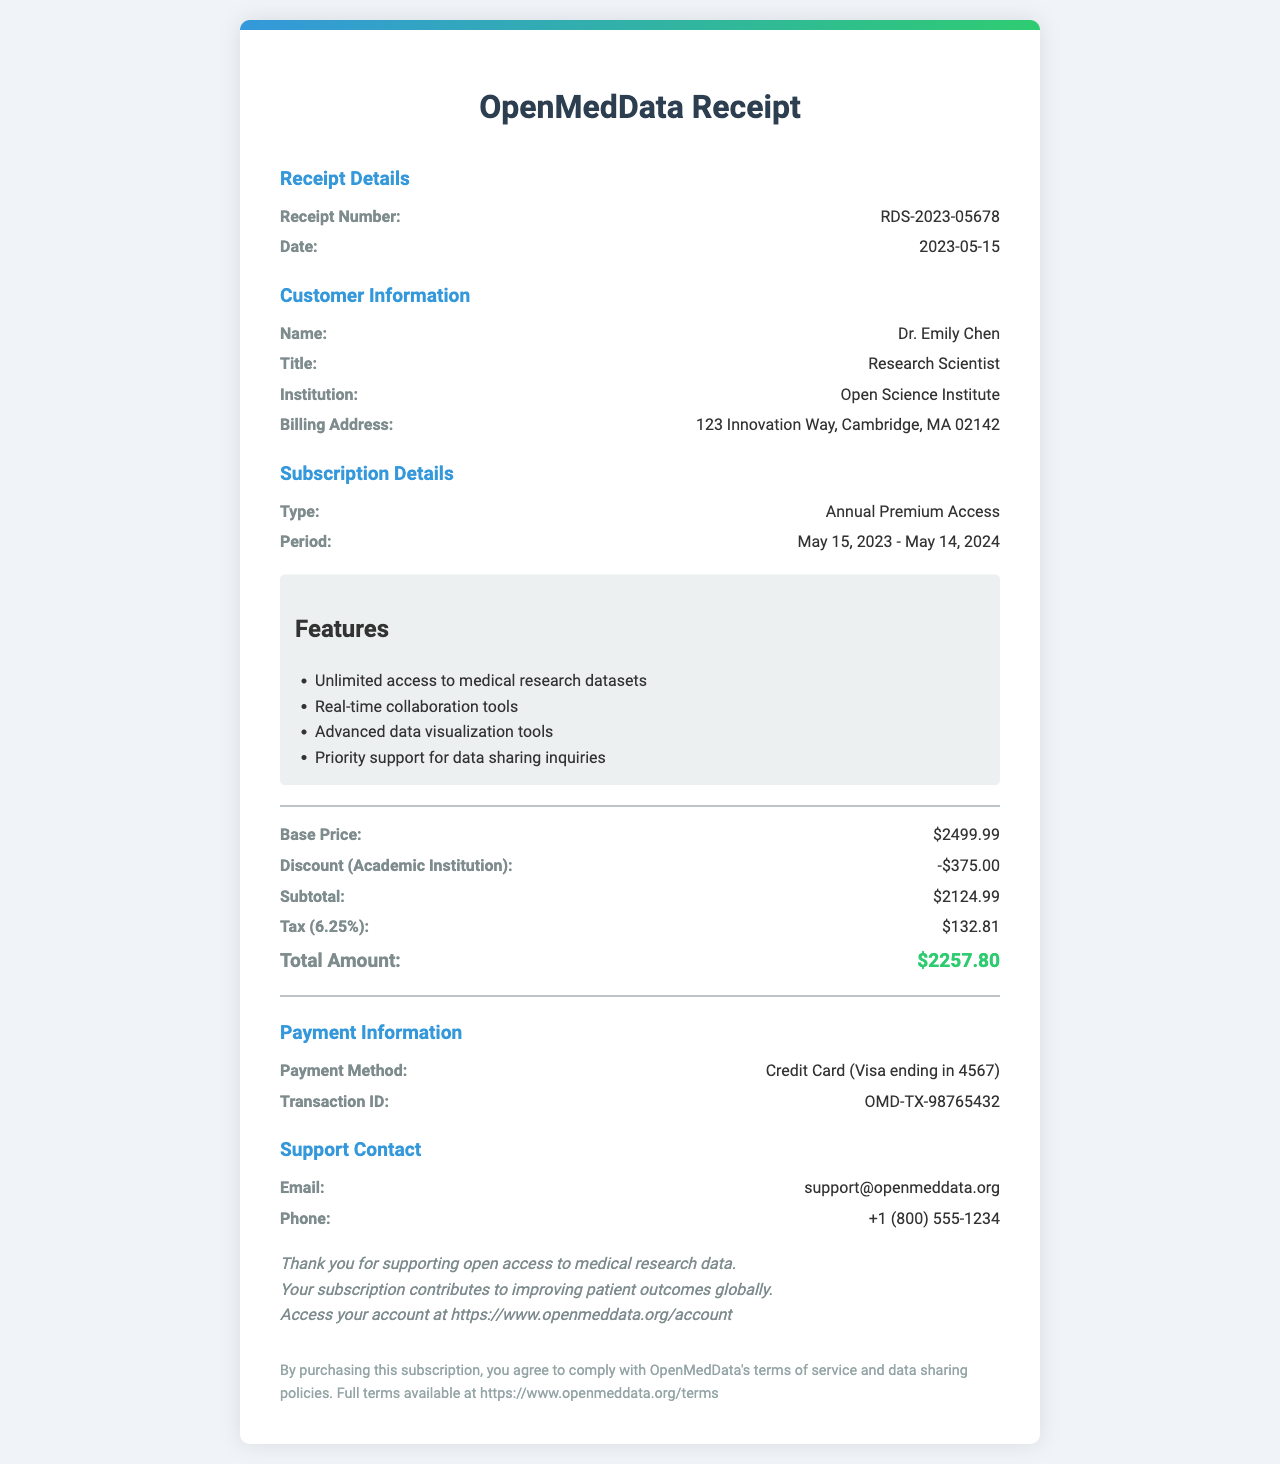What is the receipt number? The receipt number is a unique identifier for the transaction, which is RDS-2023-05678.
Answer: RDS-2023-05678 Who is the customer? The customer is identified by name, title, and institution, which is Dr. Emily Chen from the Open Science Institute.
Answer: Dr. Emily Chen What is the subscription type? The subscription type refers to the kind of access purchased, which is Annual Premium Access.
Answer: Annual Premium Access What discount was applied? The receipt shows the type of discount offered, which is an Academic Institution discount of 15%.
Answer: Academic Institution What is the total amount paid? The total amount includes the subtotal and applicable tax which sums up to $2257.80.
Answer: $2257.80 What are the primary features included? The features included in the subscription highlight tools for research, specifically listing four services available to the user.
Answer: Unlimited access to medical research datasets When does the subscription period start and end? The subscription period indicates the validity from May 15, 2023, to May 14, 2024.
Answer: May 15, 2023 - May 14, 2024 What is the tax rate applied? The tax rate is specified as a percentage applied to the subtotal, which is 6.25%.
Answer: 6.25% What method of payment was used? The receipt indicates the payment method, which specifies a credit card type and the last four digits of the card used for this transaction.
Answer: Credit Card (Visa ending in 4567) 